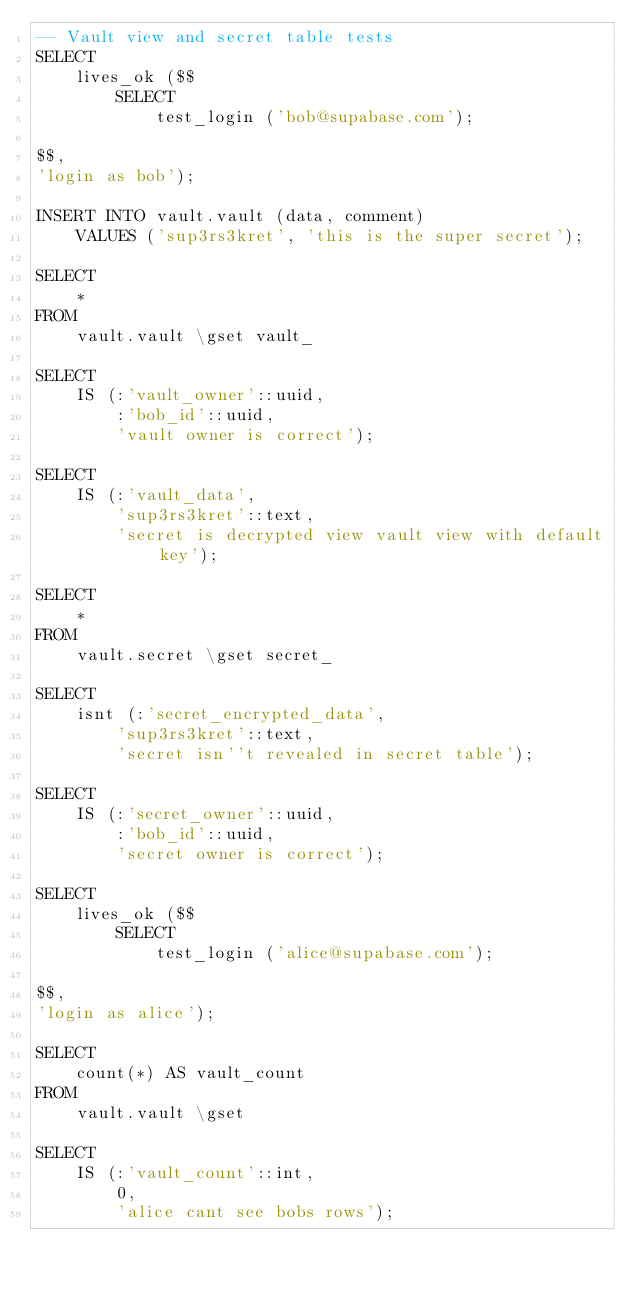<code> <loc_0><loc_0><loc_500><loc_500><_SQL_>-- Vault view and secret table tests
SELECT
    lives_ok ($$
        SELECT
            test_login ('bob@supabase.com');

$$,
'login as bob');

INSERT INTO vault.vault (data, comment)
    VALUES ('sup3rs3kret', 'this is the super secret');

SELECT
    *
FROM
    vault.vault \gset vault_

SELECT
    IS (:'vault_owner'::uuid,
        :'bob_id'::uuid,
        'vault owner is correct');

SELECT
    IS (:'vault_data',
        'sup3rs3kret'::text,
        'secret is decrypted view vault view with default key');

SELECT
    *
FROM
    vault.secret \gset secret_

SELECT
    isnt (:'secret_encrypted_data',
        'sup3rs3kret'::text,
        'secret isn''t revealed in secret table');

SELECT
    IS (:'secret_owner'::uuid,
        :'bob_id'::uuid,
        'secret owner is correct');

SELECT
    lives_ok ($$
        SELECT
            test_login ('alice@supabase.com');

$$,
'login as alice');

SELECT
    count(*) AS vault_count
FROM
    vault.vault \gset

SELECT
    IS (:'vault_count'::int,
        0,
        'alice cant see bobs rows');

</code> 